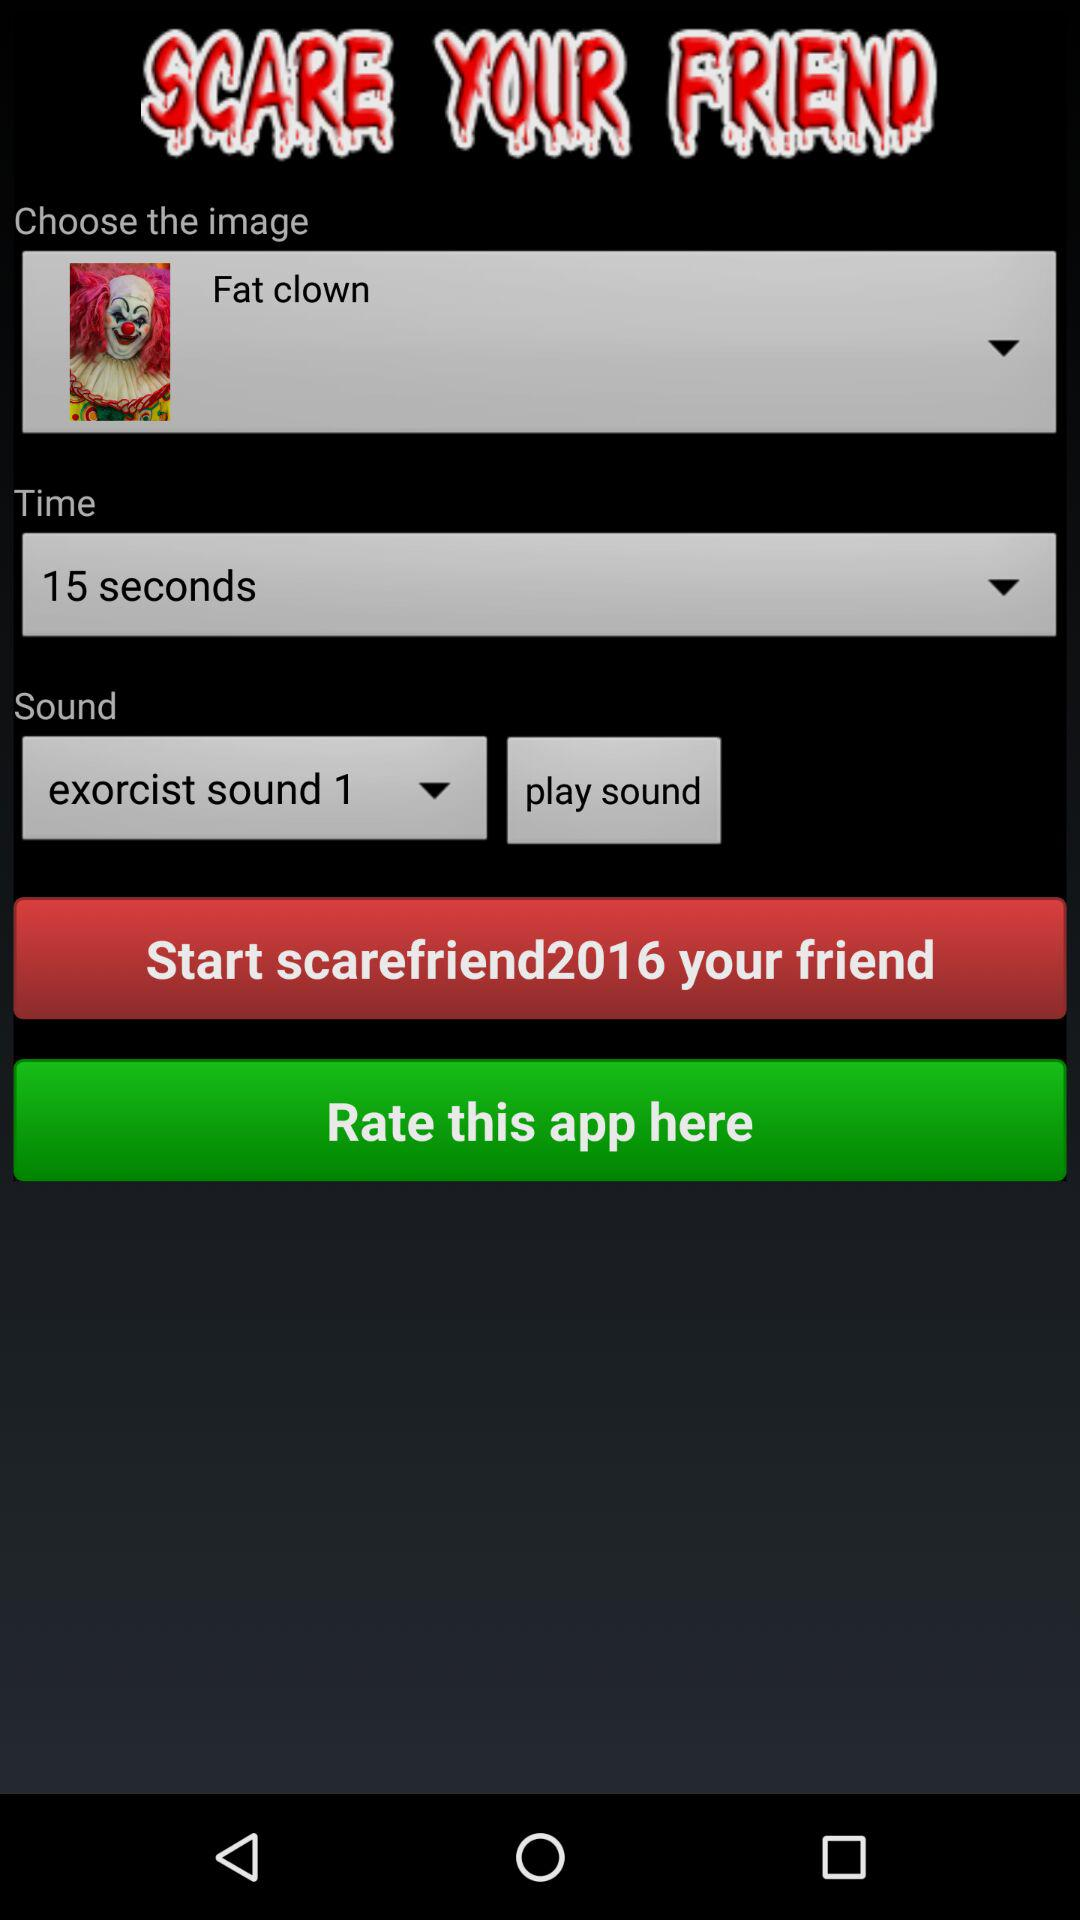Which is the selected "Sound"? The selected "Sound" is "exorcist sound 1". 